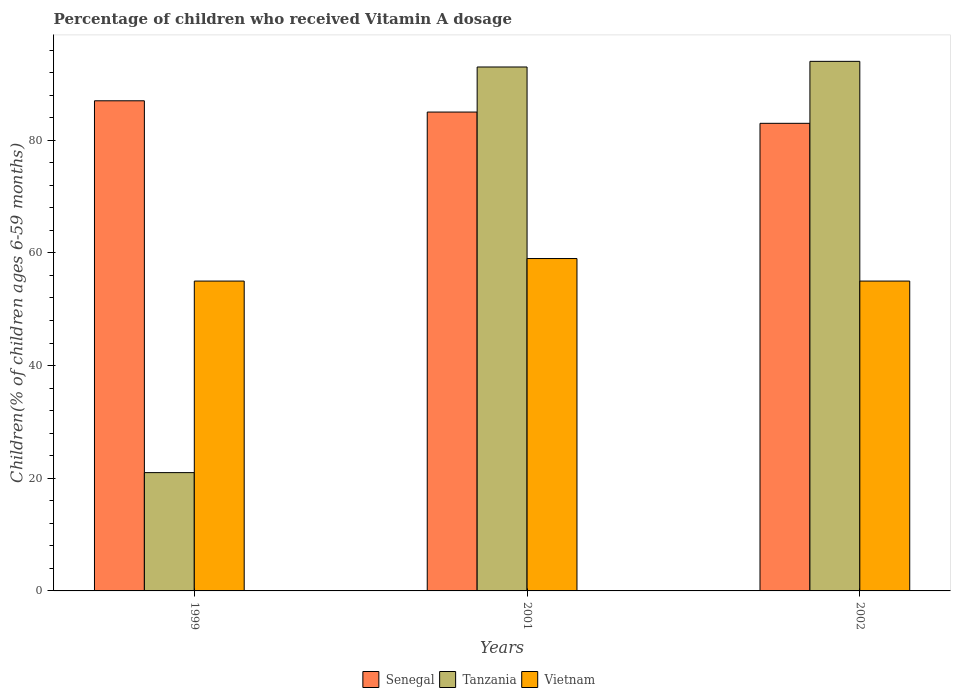How many groups of bars are there?
Ensure brevity in your answer.  3. Are the number of bars per tick equal to the number of legend labels?
Give a very brief answer. Yes. What is the label of the 2nd group of bars from the left?
Provide a short and direct response. 2001. In how many cases, is the number of bars for a given year not equal to the number of legend labels?
Offer a terse response. 0. What is the percentage of children who received Vitamin A dosage in Tanzania in 2001?
Ensure brevity in your answer.  93. In which year was the percentage of children who received Vitamin A dosage in Senegal maximum?
Provide a short and direct response. 1999. In which year was the percentage of children who received Vitamin A dosage in Senegal minimum?
Offer a very short reply. 2002. What is the total percentage of children who received Vitamin A dosage in Vietnam in the graph?
Offer a very short reply. 169. What is the average percentage of children who received Vitamin A dosage in Tanzania per year?
Give a very brief answer. 69.33. In the year 2001, what is the difference between the percentage of children who received Vitamin A dosage in Tanzania and percentage of children who received Vitamin A dosage in Senegal?
Offer a very short reply. 8. What is the ratio of the percentage of children who received Vitamin A dosage in Tanzania in 1999 to that in 2001?
Provide a succinct answer. 0.23. Is the difference between the percentage of children who received Vitamin A dosage in Tanzania in 1999 and 2002 greater than the difference between the percentage of children who received Vitamin A dosage in Senegal in 1999 and 2002?
Your answer should be compact. No. What is the difference between the highest and the lowest percentage of children who received Vitamin A dosage in Tanzania?
Provide a short and direct response. 73. In how many years, is the percentage of children who received Vitamin A dosage in Tanzania greater than the average percentage of children who received Vitamin A dosage in Tanzania taken over all years?
Your answer should be very brief. 2. Is the sum of the percentage of children who received Vitamin A dosage in Tanzania in 1999 and 2001 greater than the maximum percentage of children who received Vitamin A dosage in Senegal across all years?
Keep it short and to the point. Yes. What does the 3rd bar from the left in 1999 represents?
Offer a very short reply. Vietnam. What does the 2nd bar from the right in 2002 represents?
Your response must be concise. Tanzania. How many bars are there?
Offer a very short reply. 9. Are all the bars in the graph horizontal?
Your response must be concise. No. What is the difference between two consecutive major ticks on the Y-axis?
Provide a short and direct response. 20. Are the values on the major ticks of Y-axis written in scientific E-notation?
Offer a very short reply. No. Does the graph contain grids?
Offer a terse response. No. How many legend labels are there?
Your answer should be compact. 3. What is the title of the graph?
Keep it short and to the point. Percentage of children who received Vitamin A dosage. What is the label or title of the Y-axis?
Your response must be concise. Children(% of children ages 6-59 months). What is the Children(% of children ages 6-59 months) of Senegal in 1999?
Provide a short and direct response. 87. What is the Children(% of children ages 6-59 months) in Vietnam in 1999?
Provide a short and direct response. 55. What is the Children(% of children ages 6-59 months) of Senegal in 2001?
Your answer should be compact. 85. What is the Children(% of children ages 6-59 months) of Tanzania in 2001?
Offer a very short reply. 93. What is the Children(% of children ages 6-59 months) in Vietnam in 2001?
Provide a short and direct response. 59. What is the Children(% of children ages 6-59 months) in Tanzania in 2002?
Ensure brevity in your answer.  94. Across all years, what is the maximum Children(% of children ages 6-59 months) of Senegal?
Ensure brevity in your answer.  87. Across all years, what is the maximum Children(% of children ages 6-59 months) in Tanzania?
Offer a terse response. 94. Across all years, what is the maximum Children(% of children ages 6-59 months) in Vietnam?
Ensure brevity in your answer.  59. Across all years, what is the minimum Children(% of children ages 6-59 months) in Senegal?
Give a very brief answer. 83. Across all years, what is the minimum Children(% of children ages 6-59 months) in Vietnam?
Keep it short and to the point. 55. What is the total Children(% of children ages 6-59 months) in Senegal in the graph?
Provide a short and direct response. 255. What is the total Children(% of children ages 6-59 months) of Tanzania in the graph?
Your answer should be very brief. 208. What is the total Children(% of children ages 6-59 months) of Vietnam in the graph?
Your answer should be very brief. 169. What is the difference between the Children(% of children ages 6-59 months) in Senegal in 1999 and that in 2001?
Your answer should be compact. 2. What is the difference between the Children(% of children ages 6-59 months) in Tanzania in 1999 and that in 2001?
Ensure brevity in your answer.  -72. What is the difference between the Children(% of children ages 6-59 months) of Vietnam in 1999 and that in 2001?
Ensure brevity in your answer.  -4. What is the difference between the Children(% of children ages 6-59 months) of Senegal in 1999 and that in 2002?
Give a very brief answer. 4. What is the difference between the Children(% of children ages 6-59 months) in Tanzania in 1999 and that in 2002?
Your answer should be compact. -73. What is the difference between the Children(% of children ages 6-59 months) in Vietnam in 1999 and that in 2002?
Provide a short and direct response. 0. What is the difference between the Children(% of children ages 6-59 months) in Senegal in 2001 and that in 2002?
Keep it short and to the point. 2. What is the difference between the Children(% of children ages 6-59 months) of Tanzania in 2001 and that in 2002?
Provide a succinct answer. -1. What is the difference between the Children(% of children ages 6-59 months) in Senegal in 1999 and the Children(% of children ages 6-59 months) in Tanzania in 2001?
Make the answer very short. -6. What is the difference between the Children(% of children ages 6-59 months) in Senegal in 1999 and the Children(% of children ages 6-59 months) in Vietnam in 2001?
Your response must be concise. 28. What is the difference between the Children(% of children ages 6-59 months) of Tanzania in 1999 and the Children(% of children ages 6-59 months) of Vietnam in 2001?
Keep it short and to the point. -38. What is the difference between the Children(% of children ages 6-59 months) in Senegal in 1999 and the Children(% of children ages 6-59 months) in Vietnam in 2002?
Your response must be concise. 32. What is the difference between the Children(% of children ages 6-59 months) of Tanzania in 1999 and the Children(% of children ages 6-59 months) of Vietnam in 2002?
Provide a short and direct response. -34. What is the difference between the Children(% of children ages 6-59 months) of Senegal in 2001 and the Children(% of children ages 6-59 months) of Tanzania in 2002?
Keep it short and to the point. -9. What is the difference between the Children(% of children ages 6-59 months) of Senegal in 2001 and the Children(% of children ages 6-59 months) of Vietnam in 2002?
Offer a terse response. 30. What is the average Children(% of children ages 6-59 months) in Senegal per year?
Keep it short and to the point. 85. What is the average Children(% of children ages 6-59 months) in Tanzania per year?
Offer a terse response. 69.33. What is the average Children(% of children ages 6-59 months) of Vietnam per year?
Offer a terse response. 56.33. In the year 1999, what is the difference between the Children(% of children ages 6-59 months) of Senegal and Children(% of children ages 6-59 months) of Tanzania?
Give a very brief answer. 66. In the year 1999, what is the difference between the Children(% of children ages 6-59 months) of Senegal and Children(% of children ages 6-59 months) of Vietnam?
Provide a short and direct response. 32. In the year 1999, what is the difference between the Children(% of children ages 6-59 months) of Tanzania and Children(% of children ages 6-59 months) of Vietnam?
Provide a short and direct response. -34. In the year 2001, what is the difference between the Children(% of children ages 6-59 months) of Senegal and Children(% of children ages 6-59 months) of Tanzania?
Your response must be concise. -8. In the year 2001, what is the difference between the Children(% of children ages 6-59 months) in Senegal and Children(% of children ages 6-59 months) in Vietnam?
Offer a terse response. 26. In the year 2001, what is the difference between the Children(% of children ages 6-59 months) of Tanzania and Children(% of children ages 6-59 months) of Vietnam?
Your answer should be compact. 34. In the year 2002, what is the difference between the Children(% of children ages 6-59 months) in Senegal and Children(% of children ages 6-59 months) in Vietnam?
Provide a succinct answer. 28. In the year 2002, what is the difference between the Children(% of children ages 6-59 months) of Tanzania and Children(% of children ages 6-59 months) of Vietnam?
Provide a short and direct response. 39. What is the ratio of the Children(% of children ages 6-59 months) in Senegal in 1999 to that in 2001?
Your answer should be compact. 1.02. What is the ratio of the Children(% of children ages 6-59 months) of Tanzania in 1999 to that in 2001?
Your answer should be very brief. 0.23. What is the ratio of the Children(% of children ages 6-59 months) of Vietnam in 1999 to that in 2001?
Offer a terse response. 0.93. What is the ratio of the Children(% of children ages 6-59 months) in Senegal in 1999 to that in 2002?
Ensure brevity in your answer.  1.05. What is the ratio of the Children(% of children ages 6-59 months) in Tanzania in 1999 to that in 2002?
Offer a terse response. 0.22. What is the ratio of the Children(% of children ages 6-59 months) in Vietnam in 1999 to that in 2002?
Offer a terse response. 1. What is the ratio of the Children(% of children ages 6-59 months) in Senegal in 2001 to that in 2002?
Offer a very short reply. 1.02. What is the ratio of the Children(% of children ages 6-59 months) of Vietnam in 2001 to that in 2002?
Provide a succinct answer. 1.07. What is the difference between the highest and the lowest Children(% of children ages 6-59 months) in Tanzania?
Your response must be concise. 73. 